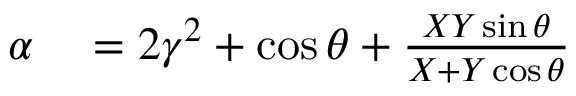Convert formula to latex. <formula><loc_0><loc_0><loc_500><loc_500>\begin{array} { r l } { \alpha } & = 2 \gamma ^ { 2 } + \cos \theta + \frac { X Y \sin \theta } { X + Y \cos \theta } } \end{array}</formula> 